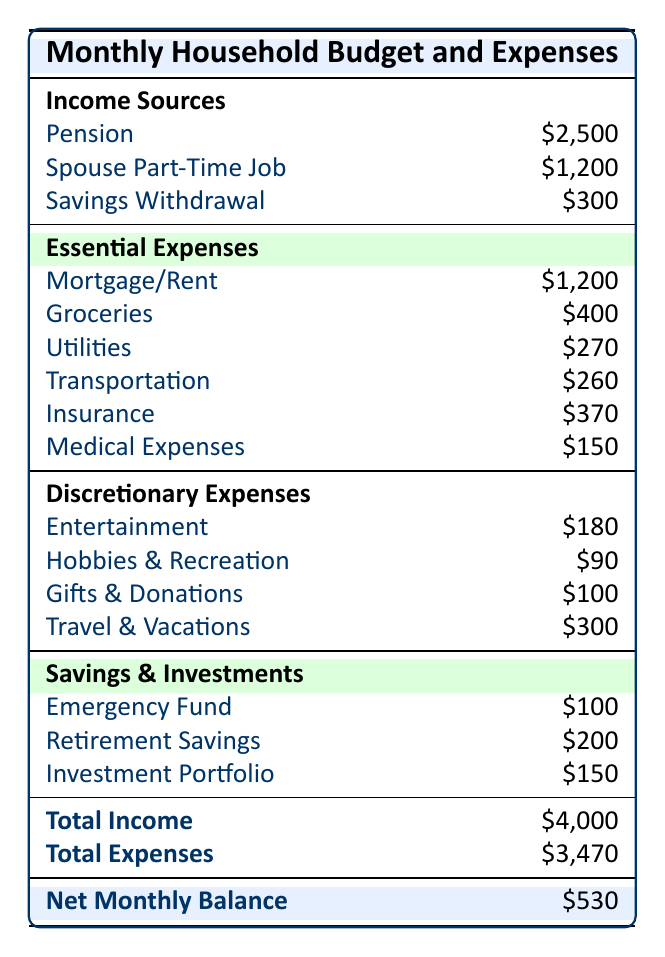What is the total income for the household? The table lists the income sources: Pension ($2,500), Spouse Part-Time Job ($1,200), and Savings Withdrawal ($300). Adding these amounts gives: $2,500 + $1,200 + $300 = $4,000.
Answer: 4,000 What is the total amount spent on essential expenses? The table details the essential expenses and their totals as follows: Mortgage/Rent ($1,200), Groceries ($400), Utilities ($270), Transportation ($260), Insurance ($370), and Medical Expenses ($150). Summing these gives: $1,200 + $400 + $270 + $260 + $370 + $150 = $2,650.
Answer: 2,650 Is the total amount saved greater than $400? The total of savings and investments is $450 as indicated in the table. Since $450 is greater than $400, the statement is true.
Answer: Yes What percentage of total income is spent on discretionary expenses? The total discretionary expenses are $370. To find the percentage of total income ($4,000) spent on discretionary expenses, use the formula: ($370 / $4,000) * 100 = 9.25%.
Answer: 9.25% How much more is spent on insurance than on medical expenses? The total spent on insurance is $370, and the total for medical expenses is $150. To find the difference: $370 - $150 = $220.
Answer: 220 Do total expenses exceed total income? The table shows total expenses are $3,470 and total income is $4,000. Since $3,470 is less than $4,000, the answer is no.
Answer: No What is the total cost of entertainment? The entertainment category includes Restaurants ($100), Movies/Concerts ($50), and Subscriptions ($30). Adding these gives: $100 + $50 + $30 = $180.
Answer: 180 If the household wanted to cut discretionary expenses by 20%, how much would that be? The total discretionary expenses are $370. To find 20% of this amount, calculate: $370 * 0.20 = $74.
Answer: 74 How much do they spend on transportation compared to groceries? Transportation costs total $260 and groceries cost $400. To compare, we see that $400 - $260 = $140 indicates groceries cost $140 more than transportation.
Answer: 140 